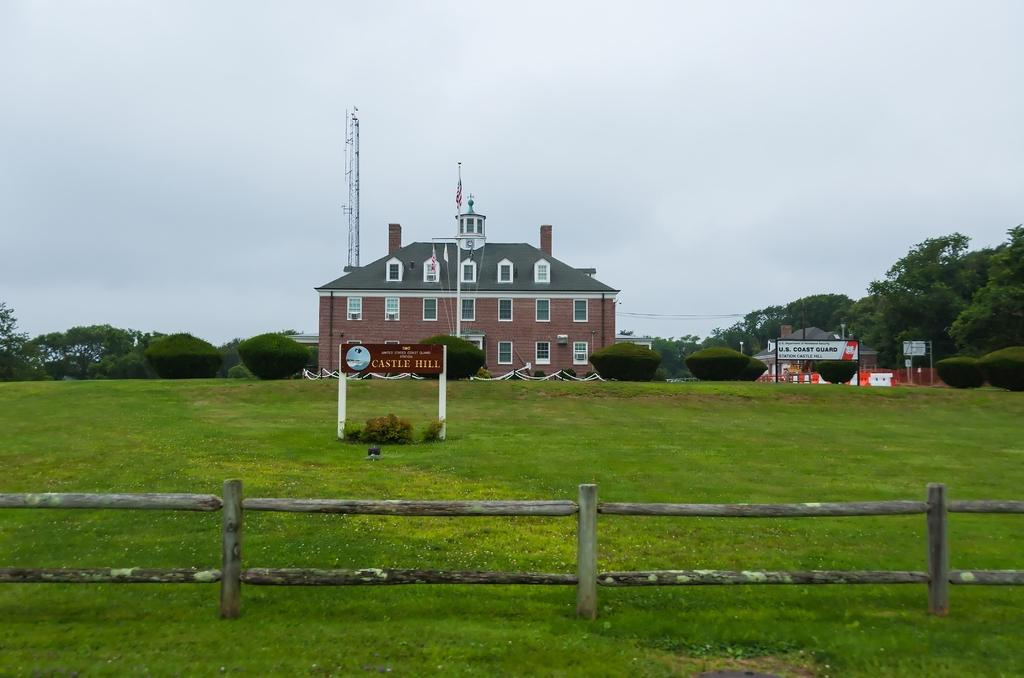What type of vegetation can be seen in the image? There is grass in the image. What can be seen in the background of the image? There are trees and a building in the background of the image. What part of the natural environment is visible in the image? The sky is visible in the background of the image. What type of blade is being used to cover the trees in the image? There is no blade or covering of trees present in the image; it features grass, trees, a building, and the sky in the background. 